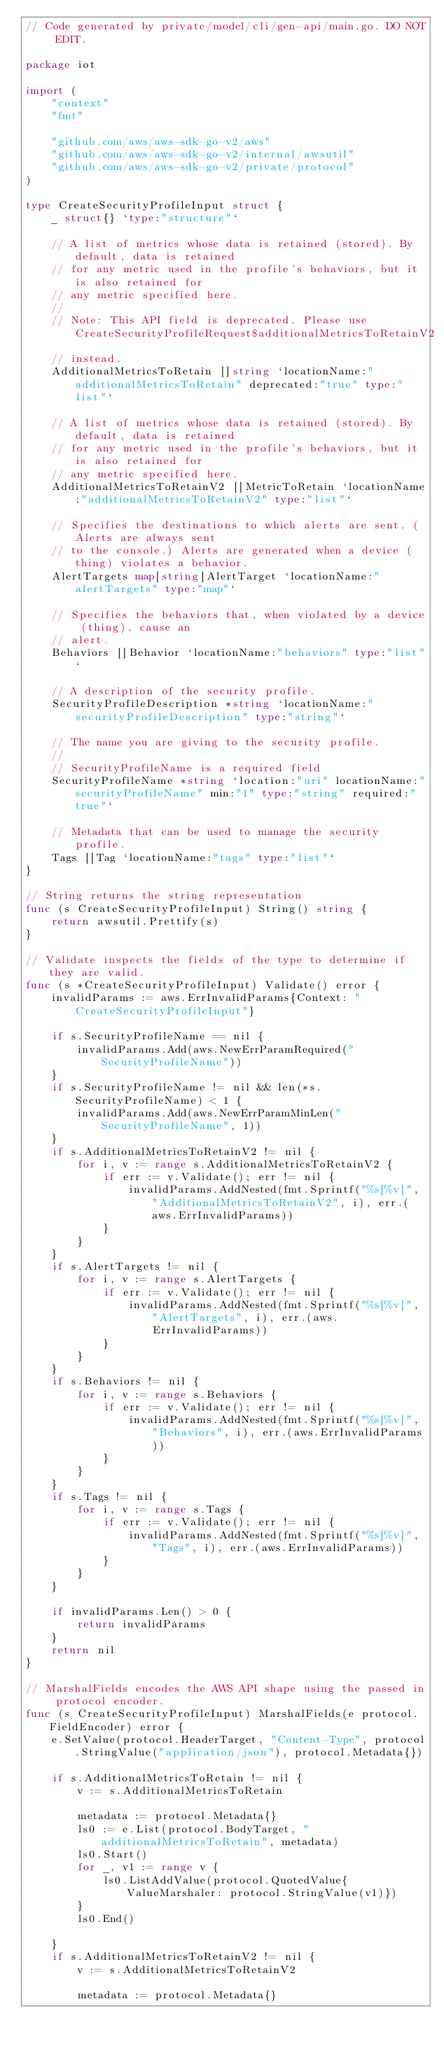<code> <loc_0><loc_0><loc_500><loc_500><_Go_>// Code generated by private/model/cli/gen-api/main.go. DO NOT EDIT.

package iot

import (
	"context"
	"fmt"

	"github.com/aws/aws-sdk-go-v2/aws"
	"github.com/aws/aws-sdk-go-v2/internal/awsutil"
	"github.com/aws/aws-sdk-go-v2/private/protocol"
)

type CreateSecurityProfileInput struct {
	_ struct{} `type:"structure"`

	// A list of metrics whose data is retained (stored). By default, data is retained
	// for any metric used in the profile's behaviors, but it is also retained for
	// any metric specified here.
	//
	// Note: This API field is deprecated. Please use CreateSecurityProfileRequest$additionalMetricsToRetainV2
	// instead.
	AdditionalMetricsToRetain []string `locationName:"additionalMetricsToRetain" deprecated:"true" type:"list"`

	// A list of metrics whose data is retained (stored). By default, data is retained
	// for any metric used in the profile's behaviors, but it is also retained for
	// any metric specified here.
	AdditionalMetricsToRetainV2 []MetricToRetain `locationName:"additionalMetricsToRetainV2" type:"list"`

	// Specifies the destinations to which alerts are sent. (Alerts are always sent
	// to the console.) Alerts are generated when a device (thing) violates a behavior.
	AlertTargets map[string]AlertTarget `locationName:"alertTargets" type:"map"`

	// Specifies the behaviors that, when violated by a device (thing), cause an
	// alert.
	Behaviors []Behavior `locationName:"behaviors" type:"list"`

	// A description of the security profile.
	SecurityProfileDescription *string `locationName:"securityProfileDescription" type:"string"`

	// The name you are giving to the security profile.
	//
	// SecurityProfileName is a required field
	SecurityProfileName *string `location:"uri" locationName:"securityProfileName" min:"1" type:"string" required:"true"`

	// Metadata that can be used to manage the security profile.
	Tags []Tag `locationName:"tags" type:"list"`
}

// String returns the string representation
func (s CreateSecurityProfileInput) String() string {
	return awsutil.Prettify(s)
}

// Validate inspects the fields of the type to determine if they are valid.
func (s *CreateSecurityProfileInput) Validate() error {
	invalidParams := aws.ErrInvalidParams{Context: "CreateSecurityProfileInput"}

	if s.SecurityProfileName == nil {
		invalidParams.Add(aws.NewErrParamRequired("SecurityProfileName"))
	}
	if s.SecurityProfileName != nil && len(*s.SecurityProfileName) < 1 {
		invalidParams.Add(aws.NewErrParamMinLen("SecurityProfileName", 1))
	}
	if s.AdditionalMetricsToRetainV2 != nil {
		for i, v := range s.AdditionalMetricsToRetainV2 {
			if err := v.Validate(); err != nil {
				invalidParams.AddNested(fmt.Sprintf("%s[%v]", "AdditionalMetricsToRetainV2", i), err.(aws.ErrInvalidParams))
			}
		}
	}
	if s.AlertTargets != nil {
		for i, v := range s.AlertTargets {
			if err := v.Validate(); err != nil {
				invalidParams.AddNested(fmt.Sprintf("%s[%v]", "AlertTargets", i), err.(aws.ErrInvalidParams))
			}
		}
	}
	if s.Behaviors != nil {
		for i, v := range s.Behaviors {
			if err := v.Validate(); err != nil {
				invalidParams.AddNested(fmt.Sprintf("%s[%v]", "Behaviors", i), err.(aws.ErrInvalidParams))
			}
		}
	}
	if s.Tags != nil {
		for i, v := range s.Tags {
			if err := v.Validate(); err != nil {
				invalidParams.AddNested(fmt.Sprintf("%s[%v]", "Tags", i), err.(aws.ErrInvalidParams))
			}
		}
	}

	if invalidParams.Len() > 0 {
		return invalidParams
	}
	return nil
}

// MarshalFields encodes the AWS API shape using the passed in protocol encoder.
func (s CreateSecurityProfileInput) MarshalFields(e protocol.FieldEncoder) error {
	e.SetValue(protocol.HeaderTarget, "Content-Type", protocol.StringValue("application/json"), protocol.Metadata{})

	if s.AdditionalMetricsToRetain != nil {
		v := s.AdditionalMetricsToRetain

		metadata := protocol.Metadata{}
		ls0 := e.List(protocol.BodyTarget, "additionalMetricsToRetain", metadata)
		ls0.Start()
		for _, v1 := range v {
			ls0.ListAddValue(protocol.QuotedValue{ValueMarshaler: protocol.StringValue(v1)})
		}
		ls0.End()

	}
	if s.AdditionalMetricsToRetainV2 != nil {
		v := s.AdditionalMetricsToRetainV2

		metadata := protocol.Metadata{}</code> 